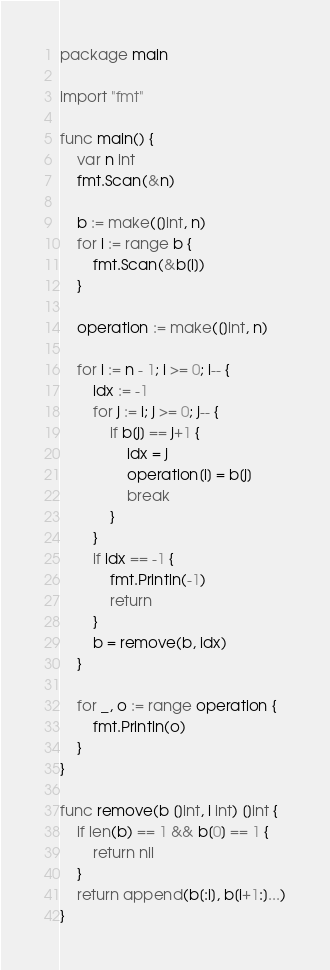<code> <loc_0><loc_0><loc_500><loc_500><_Go_>package main

import "fmt"

func main() {
	var n int
	fmt.Scan(&n)

	b := make([]int, n)
	for i := range b {
		fmt.Scan(&b[i])
	}

	operation := make([]int, n)

	for i := n - 1; i >= 0; i-- {
		idx := -1
		for j := i; j >= 0; j-- {
			if b[j] == j+1 {
				idx = j
				operation[i] = b[j]
				break
			}
		}
		if idx == -1 {
			fmt.Println(-1)
			return
		}
		b = remove(b, idx)
	}

	for _, o := range operation {
		fmt.Println(o)
	}
}

func remove(b []int, i int) []int {
	if len(b) == 1 && b[0] == 1 {
		return nil
	}
	return append(b[:i], b[i+1:]...)
}
</code> 